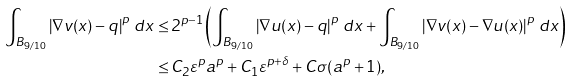Convert formula to latex. <formula><loc_0><loc_0><loc_500><loc_500>\int _ { B _ { 9 / 1 0 } } \left | \nabla v ( x ) - q \right | ^ { p } \, d x \leq \, & 2 ^ { p - 1 } \left ( \int _ { B _ { 9 / 1 0 } } \left | \nabla u ( x ) - q \right | ^ { p } \, d x + \int _ { B _ { 9 / 1 0 } } \left | \nabla v ( x ) - \nabla u ( x ) \right | ^ { p } \, d x \right ) \\ \leq \, & C _ { 2 } \varepsilon ^ { p } a ^ { p } + C _ { 1 } \varepsilon ^ { p + \delta } + C \sigma ( a ^ { p } + 1 ) ,</formula> 